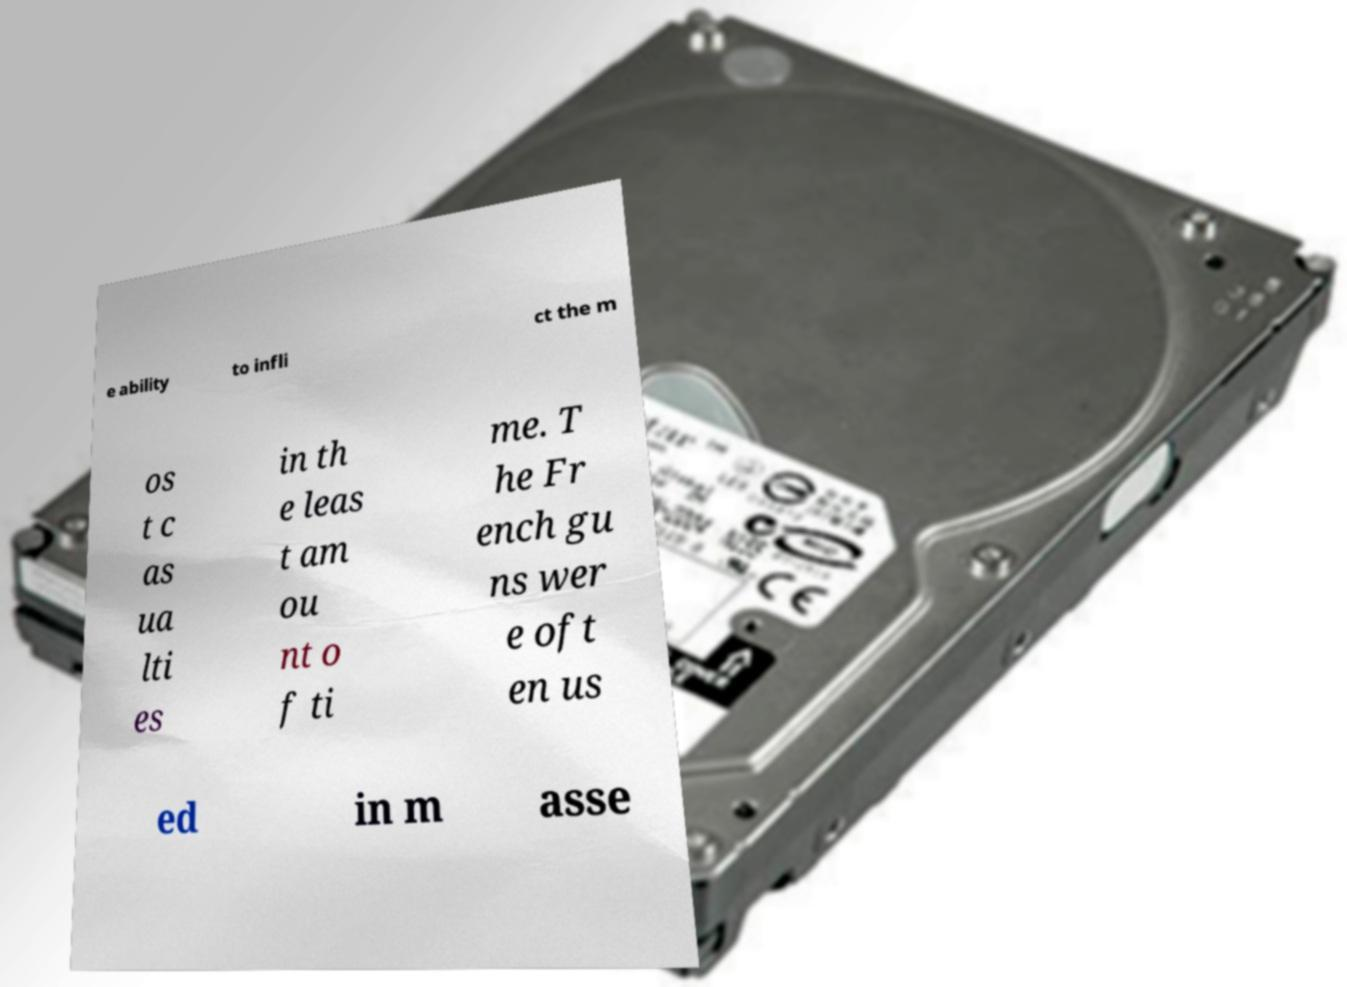Could you assist in decoding the text presented in this image and type it out clearly? e ability to infli ct the m os t c as ua lti es in th e leas t am ou nt o f ti me. T he Fr ench gu ns wer e oft en us ed in m asse 